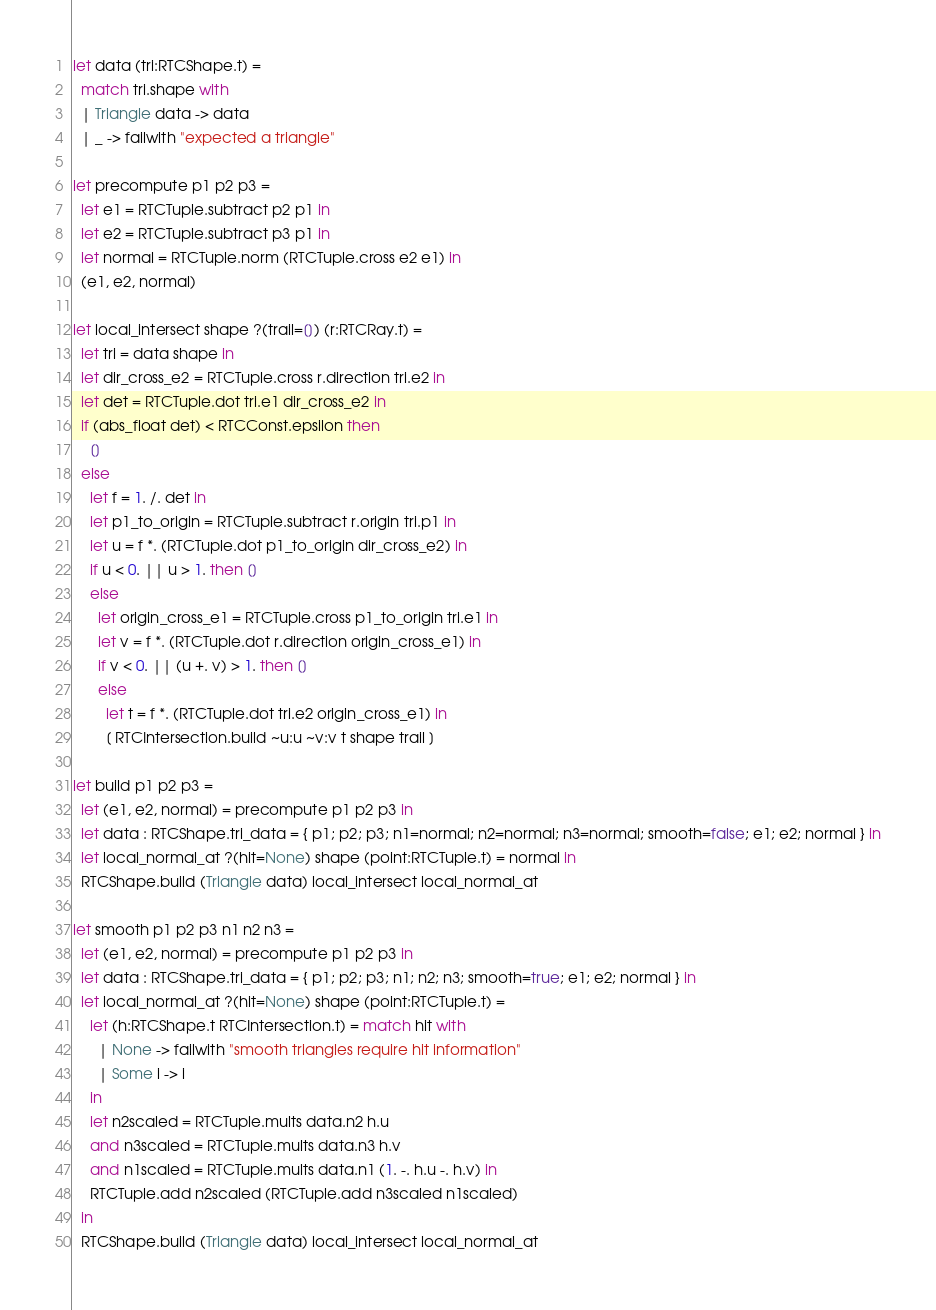Convert code to text. <code><loc_0><loc_0><loc_500><loc_500><_OCaml_>let data (tri:RTCShape.t) =
  match tri.shape with
  | Triangle data -> data
  | _ -> failwith "expected a triangle"

let precompute p1 p2 p3 =
  let e1 = RTCTuple.subtract p2 p1 in
  let e2 = RTCTuple.subtract p3 p1 in
  let normal = RTCTuple.norm (RTCTuple.cross e2 e1) in
  (e1, e2, normal)

let local_intersect shape ?(trail=[]) (r:RTCRay.t) =
  let tri = data shape in
  let dir_cross_e2 = RTCTuple.cross r.direction tri.e2 in
  let det = RTCTuple.dot tri.e1 dir_cross_e2 in
  if (abs_float det) < RTCConst.epsilon then
    []
  else
    let f = 1. /. det in
    let p1_to_origin = RTCTuple.subtract r.origin tri.p1 in
    let u = f *. (RTCTuple.dot p1_to_origin dir_cross_e2) in
    if u < 0. || u > 1. then []
    else
      let origin_cross_e1 = RTCTuple.cross p1_to_origin tri.e1 in
      let v = f *. (RTCTuple.dot r.direction origin_cross_e1) in
      if v < 0. || (u +. v) > 1. then []
      else
        let t = f *. (RTCTuple.dot tri.e2 origin_cross_e1) in
        [ RTCIntersection.build ~u:u ~v:v t shape trail ]

let build p1 p2 p3 =
  let (e1, e2, normal) = precompute p1 p2 p3 in
  let data : RTCShape.tri_data = { p1; p2; p3; n1=normal; n2=normal; n3=normal; smooth=false; e1; e2; normal } in
  let local_normal_at ?(hit=None) shape (point:RTCTuple.t) = normal in
  RTCShape.build (Triangle data) local_intersect local_normal_at

let smooth p1 p2 p3 n1 n2 n3 =
  let (e1, e2, normal) = precompute p1 p2 p3 in
  let data : RTCShape.tri_data = { p1; p2; p3; n1; n2; n3; smooth=true; e1; e2; normal } in
  let local_normal_at ?(hit=None) shape (point:RTCTuple.t) =
    let (h:RTCShape.t RTCIntersection.t) = match hit with
      | None -> failwith "smooth triangles require hit information"
      | Some i -> i
    in
    let n2scaled = RTCTuple.mults data.n2 h.u
    and n3scaled = RTCTuple.mults data.n3 h.v
    and n1scaled = RTCTuple.mults data.n1 (1. -. h.u -. h.v) in
    RTCTuple.add n2scaled (RTCTuple.add n3scaled n1scaled)
  in
  RTCShape.build (Triangle data) local_intersect local_normal_at
</code> 